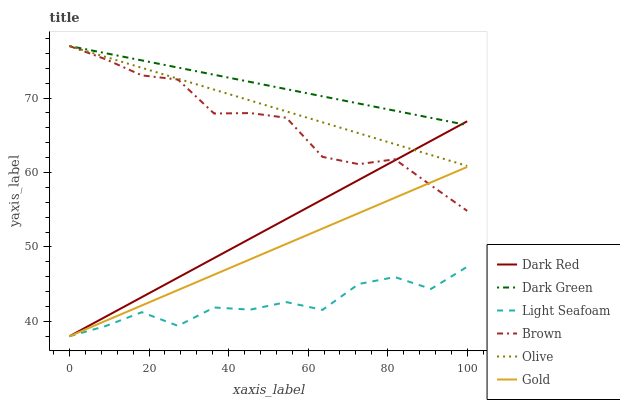Does Light Seafoam have the minimum area under the curve?
Answer yes or no. Yes. Does Dark Green have the maximum area under the curve?
Answer yes or no. Yes. Does Gold have the minimum area under the curve?
Answer yes or no. No. Does Gold have the maximum area under the curve?
Answer yes or no. No. Is Gold the smoothest?
Answer yes or no. Yes. Is Light Seafoam the roughest?
Answer yes or no. Yes. Is Dark Red the smoothest?
Answer yes or no. No. Is Dark Red the roughest?
Answer yes or no. No. Does Gold have the lowest value?
Answer yes or no. Yes. Does Olive have the lowest value?
Answer yes or no. No. Does Dark Green have the highest value?
Answer yes or no. Yes. Does Gold have the highest value?
Answer yes or no. No. Is Light Seafoam less than Brown?
Answer yes or no. Yes. Is Dark Green greater than Light Seafoam?
Answer yes or no. Yes. Does Dark Red intersect Brown?
Answer yes or no. Yes. Is Dark Red less than Brown?
Answer yes or no. No. Is Dark Red greater than Brown?
Answer yes or no. No. Does Light Seafoam intersect Brown?
Answer yes or no. No. 